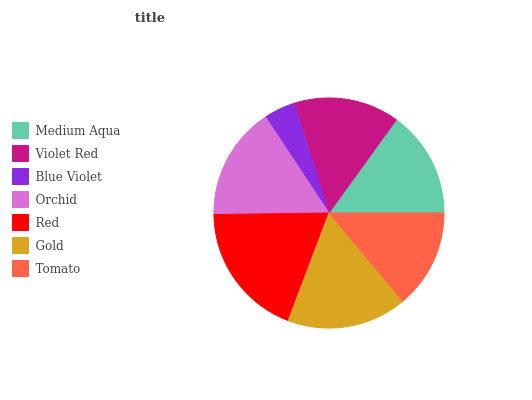Is Blue Violet the minimum?
Answer yes or no. Yes. Is Red the maximum?
Answer yes or no. Yes. Is Violet Red the minimum?
Answer yes or no. No. Is Violet Red the maximum?
Answer yes or no. No. Is Medium Aqua greater than Violet Red?
Answer yes or no. Yes. Is Violet Red less than Medium Aqua?
Answer yes or no. Yes. Is Violet Red greater than Medium Aqua?
Answer yes or no. No. Is Medium Aqua less than Violet Red?
Answer yes or no. No. Is Medium Aqua the high median?
Answer yes or no. Yes. Is Medium Aqua the low median?
Answer yes or no. Yes. Is Blue Violet the high median?
Answer yes or no. No. Is Orchid the low median?
Answer yes or no. No. 